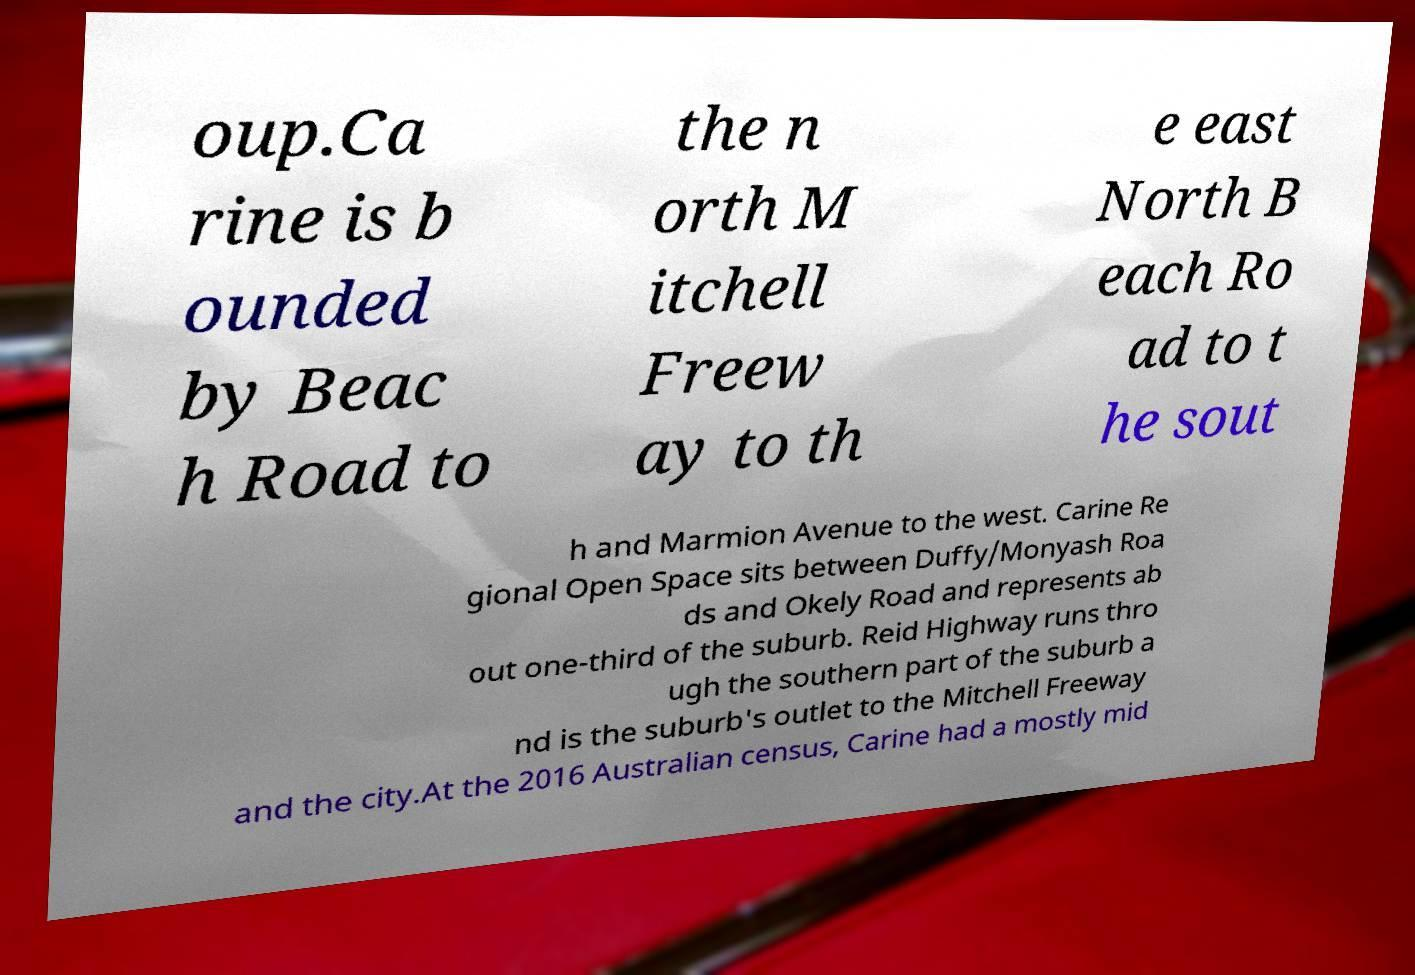I need the written content from this picture converted into text. Can you do that? oup.Ca rine is b ounded by Beac h Road to the n orth M itchell Freew ay to th e east North B each Ro ad to t he sout h and Marmion Avenue to the west. Carine Re gional Open Space sits between Duffy/Monyash Roa ds and Okely Road and represents ab out one-third of the suburb. Reid Highway runs thro ugh the southern part of the suburb a nd is the suburb's outlet to the Mitchell Freeway and the city.At the 2016 Australian census, Carine had a mostly mid 